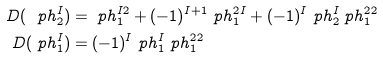<formula> <loc_0><loc_0><loc_500><loc_500>D ( \ p h ^ { I } _ { 2 } ) & = \ p h ^ { I 2 } _ { 1 } + ( - 1 ) ^ { I + 1 } \ p h ^ { 2 I } _ { 1 } + ( - 1 ) ^ { I } \ p h ^ { I } _ { 2 } \ p h ^ { 2 2 } _ { 1 } \\ D ( \ p h ^ { I } _ { 1 } ) & = ( - 1 ) ^ { I } \ p h ^ { I } _ { 1 } \ p h ^ { 2 2 } _ { 1 }</formula> 